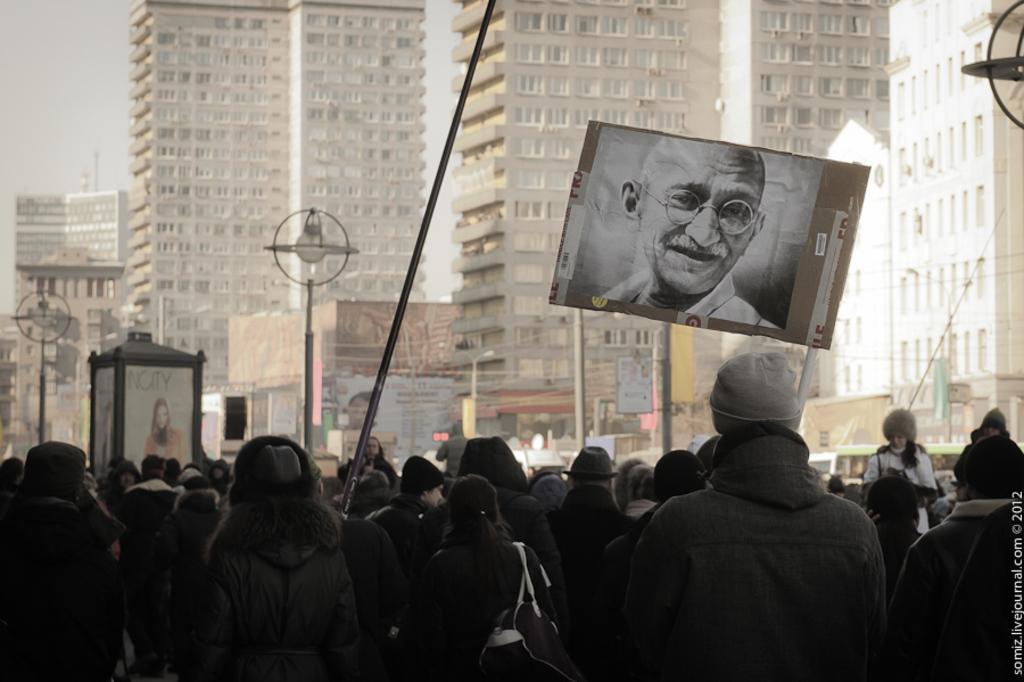In one or two sentences, can you explain what this image depicts? This is the picture of a city. In this image there are group of people standing and In the foreground there is a person holding the pluck card and there is a picture of a person on the pluck card. At the back there are buildings and poles. At the top there is sky. 